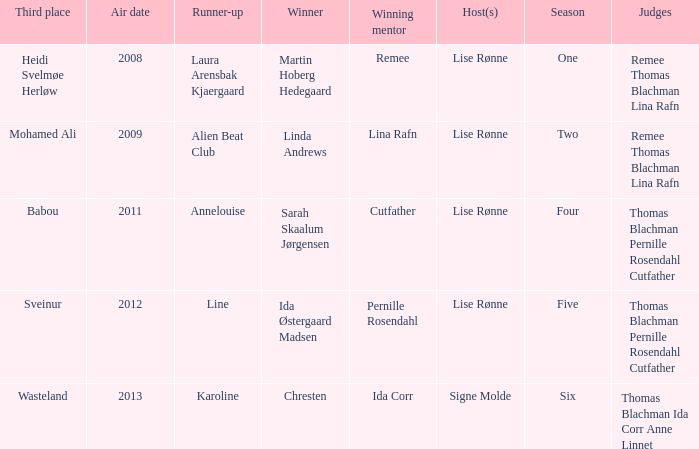Who was the runner-up in season five? Line. 